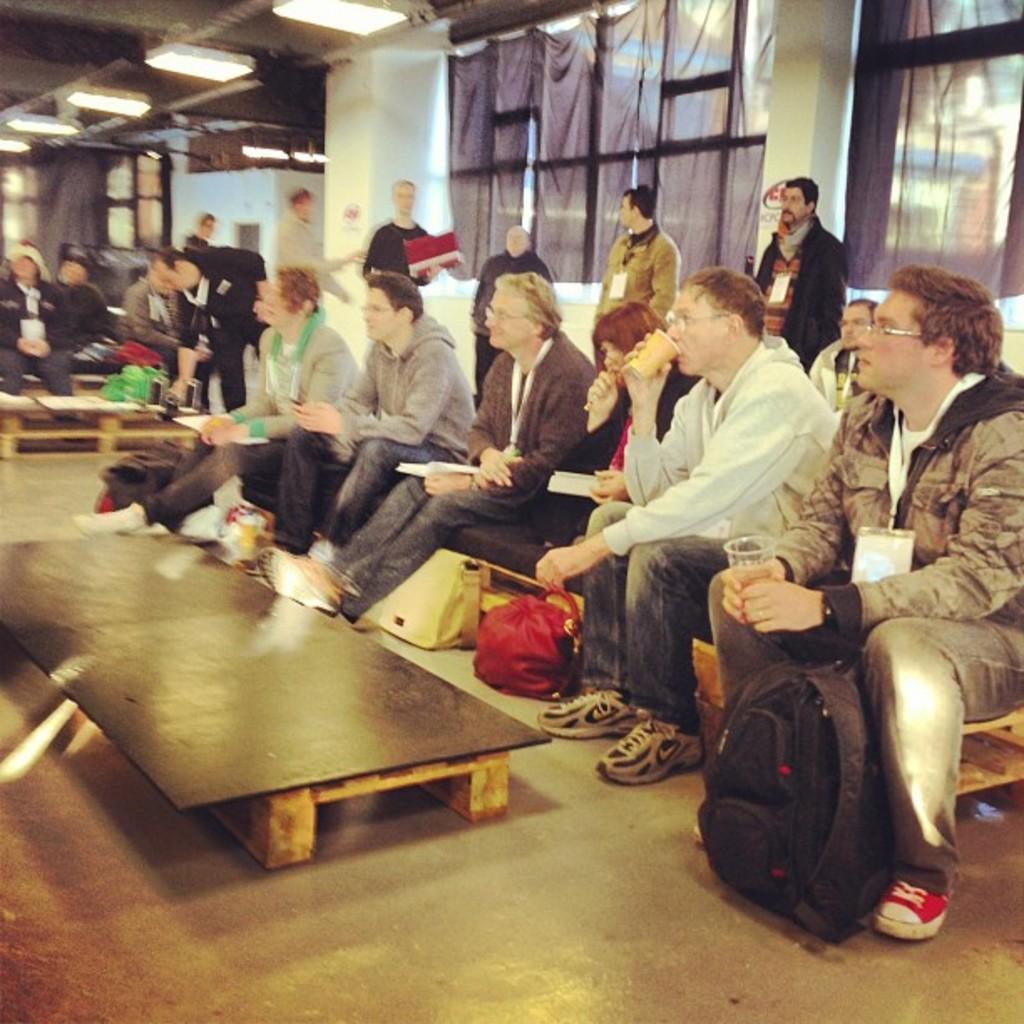Could you give a brief overview of what you see in this image? In this image I see lot of people sitting and few of them are standing. I can also see there are few bags and a table over here. In the background I can see the lights, wall and the windows. 